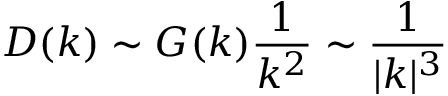<formula> <loc_0><loc_0><loc_500><loc_500>D ( k ) \sim G ( k ) { \frac { 1 } { k ^ { 2 } } } \sim { \frac { 1 } { | k | ^ { 3 } } }</formula> 